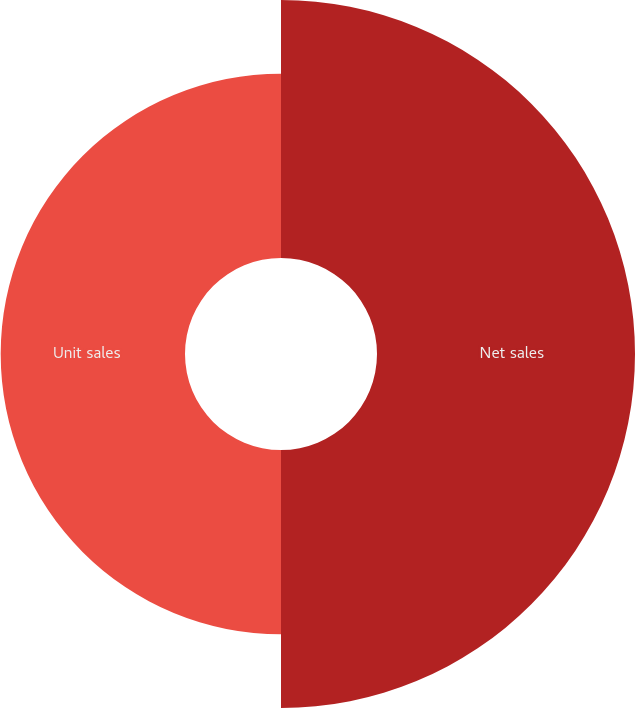Convert chart. <chart><loc_0><loc_0><loc_500><loc_500><pie_chart><fcel>Net sales<fcel>Unit sales<nl><fcel>58.33%<fcel>41.67%<nl></chart> 